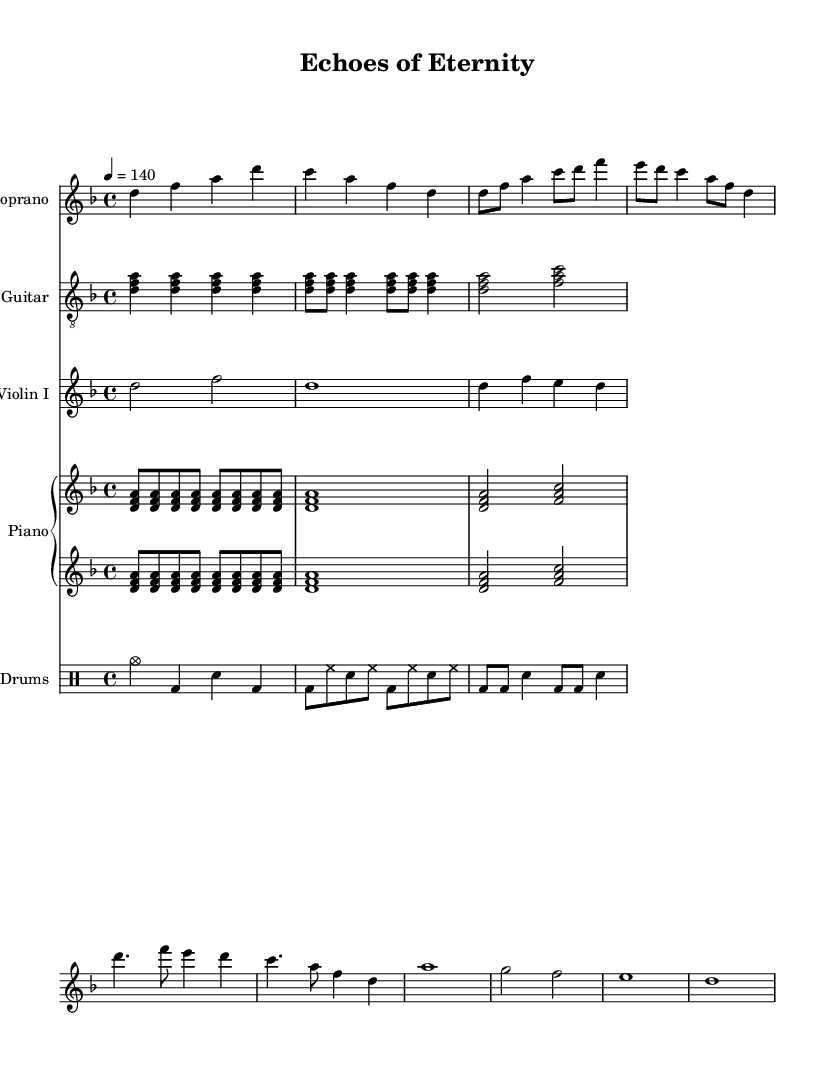What is the key signature of this music? The key signature is indicated by the sharp or flat symbols at the beginning of the staff. For this piece, it shows one flat, indicating D minor.
Answer: D minor What is the time signature of this piece? The time signature is found at the beginning of the score, indicating how many beats are in each measure. This piece has a 4/4 time signature, which means there are four beats per measure.
Answer: 4/4 What is the tempo marking for this score? The tempo marking is noted at the beginning, indicating the speed of the piece. It shows "4 = 140," which means there are 140 beats per minute.
Answer: 140 How many measures are there in the Chorus section? By counting the measures within the labeled section of the score, the Chorus has a total of four measures.
Answer: 4 What is the instrument playing the main melody in the Intro? The Intro specifically highlights the Soprano voice in the sheet music, which is notated as the main melodic line.
Answer: Soprano Which instruments are featured in the arrangement? By examining the staff names, we see instruments like Soprano, Electric Guitar, Violin I, Piano, and Drums, all of which contribute to the orchestration.
Answer: Soprano, Electric Guitar, Violin I, Piano, Drums How many distinct sections are present in this piece? The piece clearly divides into different sections, including the Intro, Verse, Chorus, and Bridge. Counting these sections shows there are four distinct parts.
Answer: 4 